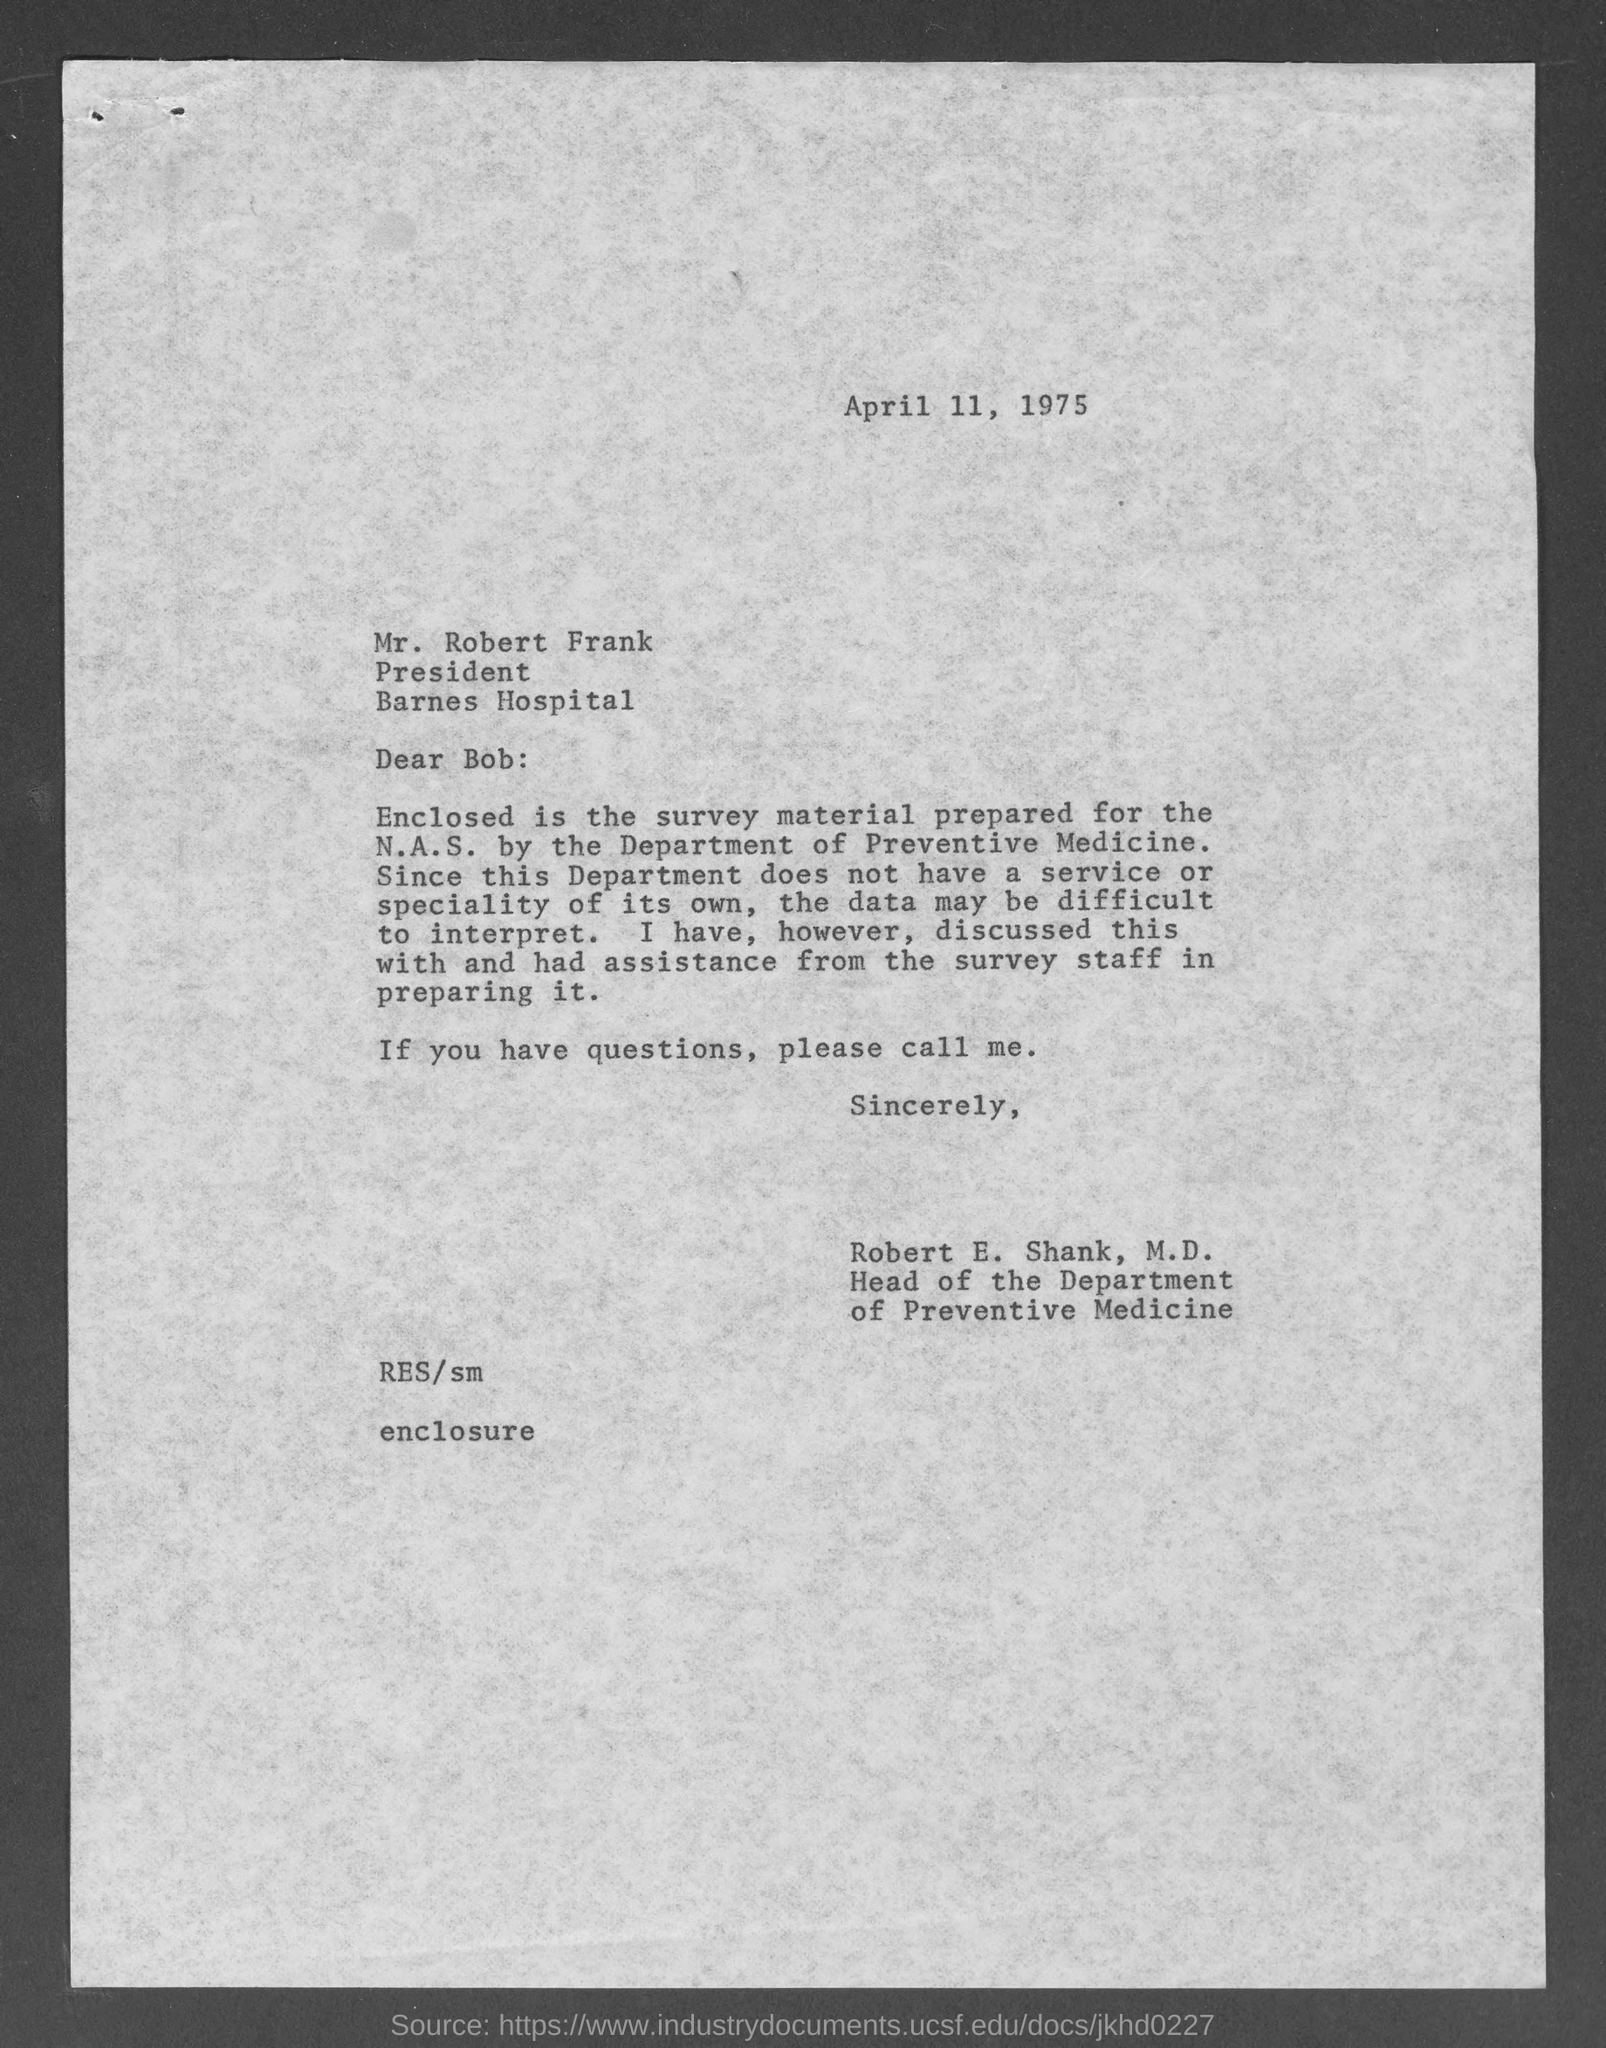When is the letter dated ?
Your answer should be compact. April 11, 1975. What is the position of mr. robert frank ?
Your response must be concise. President. To whom is this letter written to?
Ensure brevity in your answer.  Mr. Robert Frank. Who wrote this letter?
Your response must be concise. Robert E. Shank, M.D. What is the position of robert e. shank, m.d.?
Provide a succinct answer. Head of the department of Preventive Medicine. 